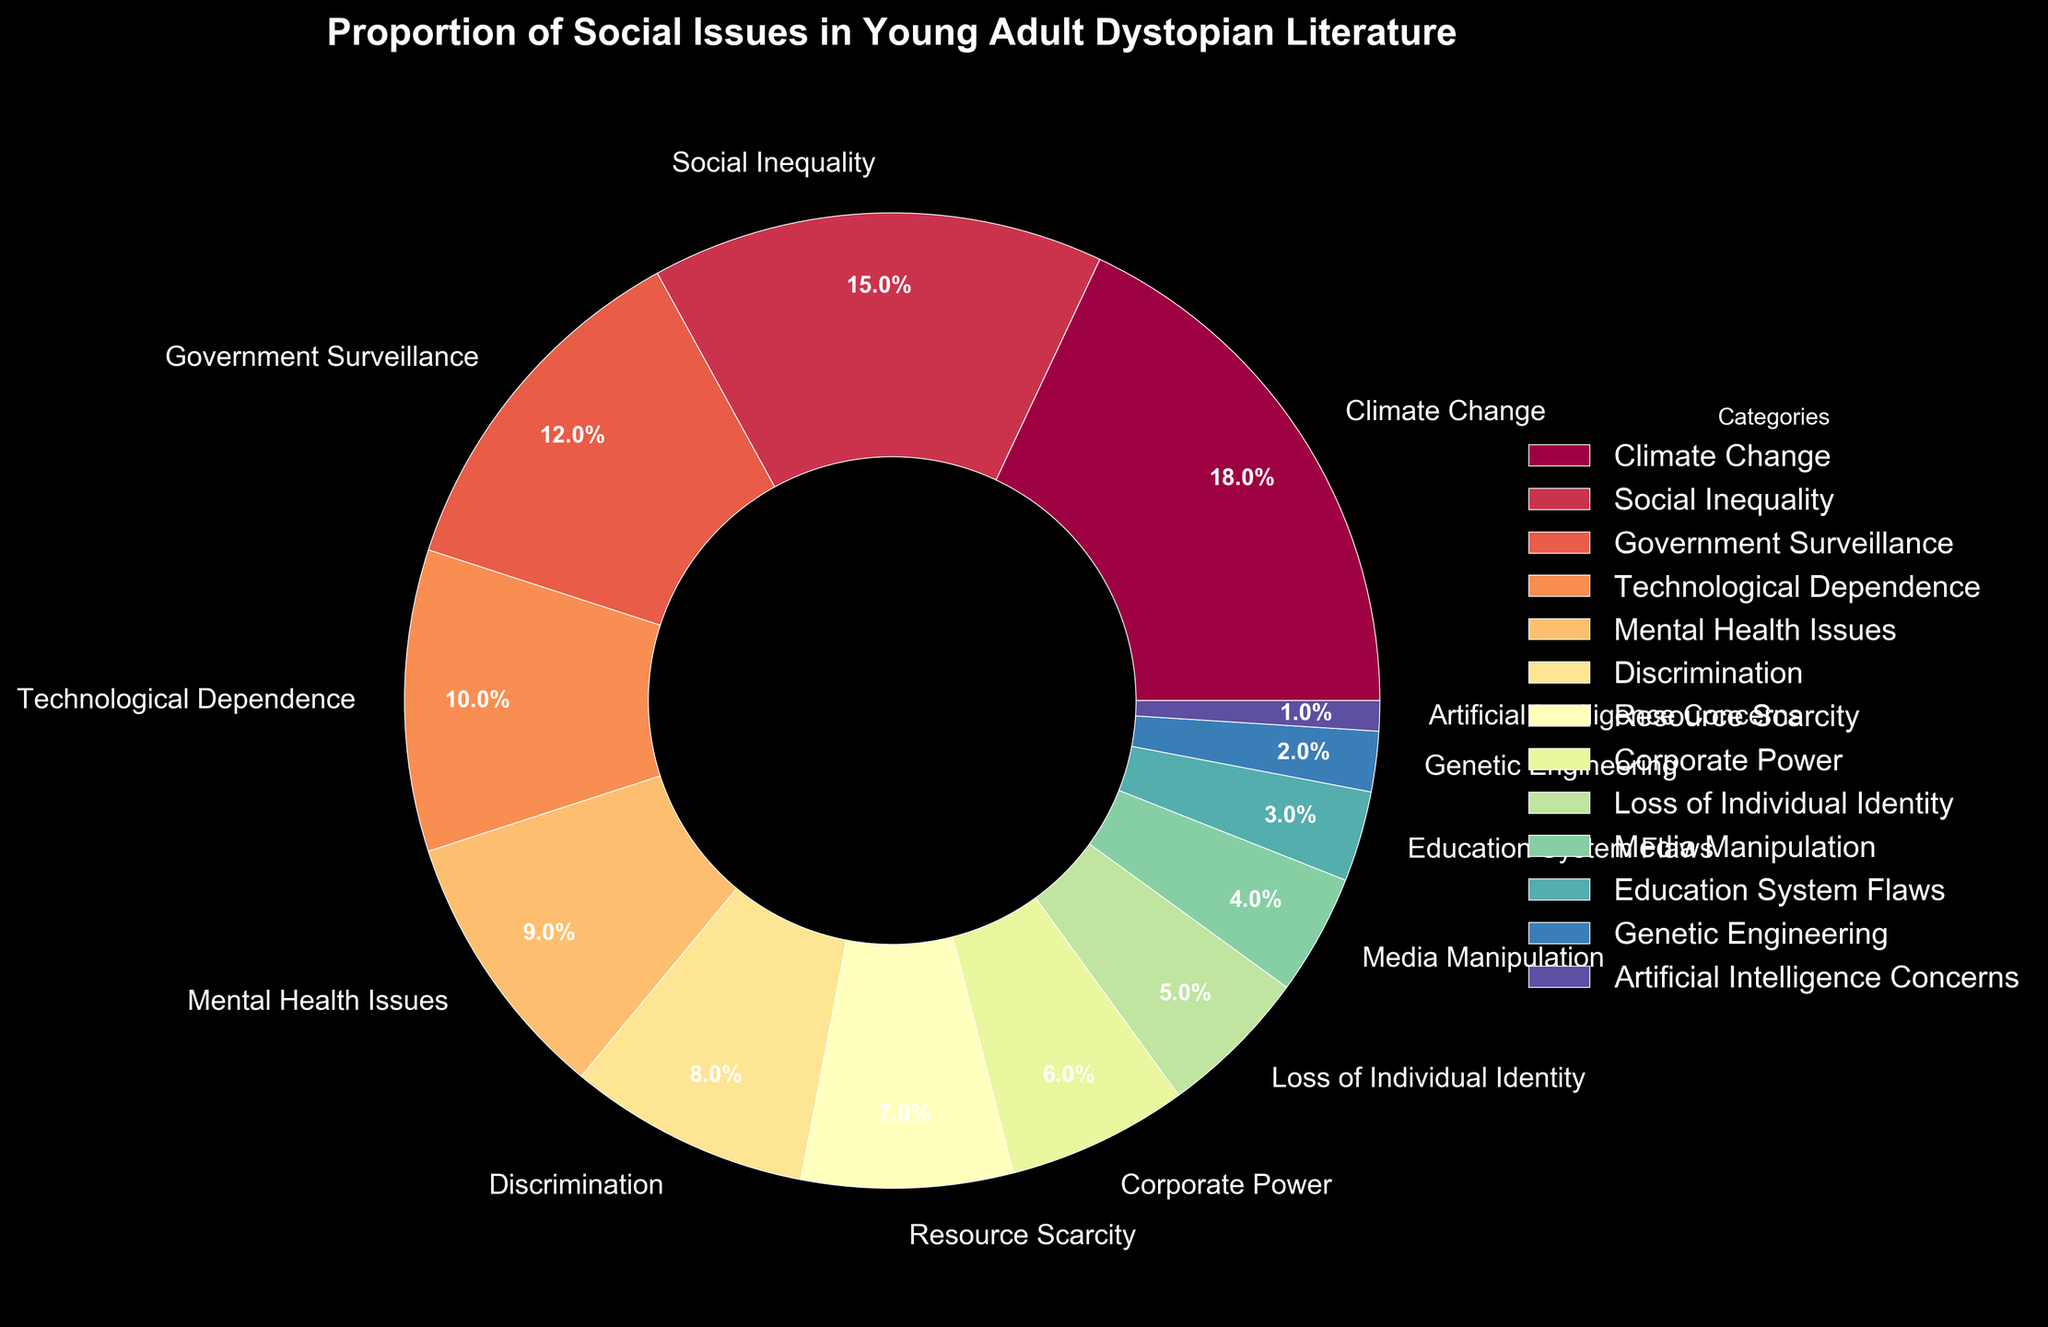What social issue is represented the most in young adult dystopian literature according to the pie chart? By looking at the pie chart, the segment representing "Climate Change" is the largest, occupying 18% of the chart.
Answer: Climate Change What is the combined percentage of "Social Inequality" and "Government Surveillance"? The percentages are 15% for Social Inequality and 12% for Government Surveillance. Adding them together, 15% + 12% = 27%.
Answer: 27% Which issue is more prevalent, "Mental Health Issues" or "Technological Dependence"? The pie chart shows "Mental Health Issues" at 9% and "Technological Dependence" at 10%. Therefore, Technological Dependence is slightly more prevalent.
Answer: Technological Dependence What is the difference in percentage between the highest and the lowest represented issues? The highest represented issue is "Climate Change" at 18% and the lowest is "Artificial Intelligence Concerns" at 1%. The difference is 18% - 1% = 17%.
Answer: 17% How many categories have a percentage less than or equal to 5%? By examining the chart, the categories that have a percentage less than or equal to 5% are "Loss of Individual Identity" (5%), "Media Manipulation" (4%), "Education System Flaws" (3%), "Genetic Engineering" (2%), and "Artificial Intelligence Concerns" (1%). There are 5 such categories.
Answer: 5 What is the total percentage of issues related to technology ("Technological Dependence" and "Artificial Intelligence Concerns")? "Technological Dependence" is at 10% and "Artificial Intelligence Concerns" is at 1%. Adding them together, 10% + 1% = 11%.
Answer: 11% How much more prevalent is "Climate Change" compared to "Resource Scarcity"? "Climate Change" is at 18% while "Resource Scarcity" is at 7%. The difference is 18% - 7% = 11%.
Answer: 11% What is the average percentage of the listed issues? There are 13 categories. The sum of their percentages is 100%. The average percentage is 100% / 13 ≈ 7.7%.
Answer: 7.7% Which issue has the smallest segment, and what is its percentage? The smallest segment corresponds to "Artificial Intelligence Concerns" with a percentage of 1%.
Answer: Artificial Intelligence Concerns 